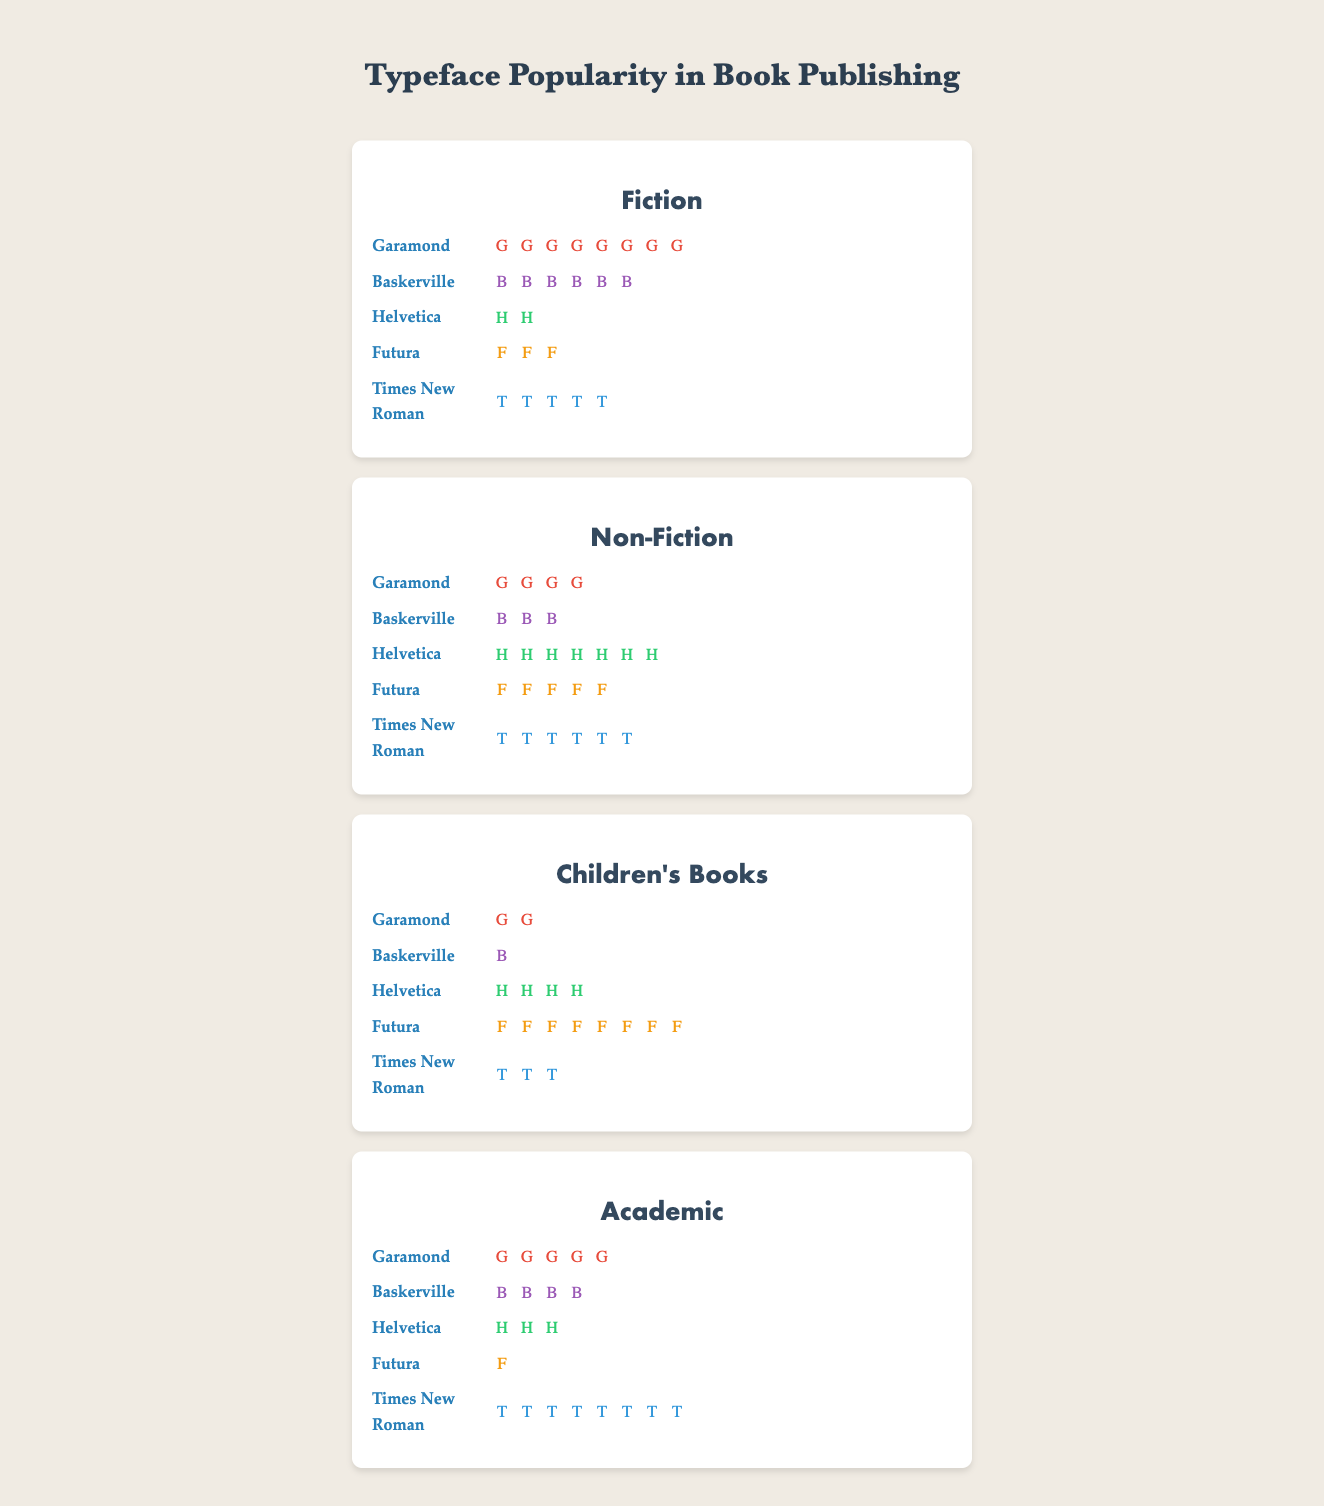What's the most popular typeface used in Fiction books? By looking at the figure, count the number of icons for each typeface in the Fiction section. Garamond has the most icons (8), making it the most popular.
Answer: Garamond Which genre uses Times New Roman the most? Compare the number of Times New Roman icons across all genres. The Academic genre has the most icons (8) for Times New Roman.
Answer: Academic How many total icons are used to represent Helvetica across all genres? Sum the number of Helvetica icons: Fiction (2) + Non-Fiction (7) + Children's Books (4) + Academic (3). The total is 2 + 7 + 4 + 3 = 16.
Answer: 16 Which typeface is used the least in Children's Books? In the Children's Books section, count the icons for each typeface. Baskerville has the least with only 1 icon.
Answer: Baskerville Between Garamond and Futura, which one is more popular in Non-Fiction? Count the number of icons for Garamond (4) and Futura (5) in the Non-Fiction section. Futura has more icons.
Answer: Futura What's the total number of icons used to represent all typefaces in the Academic genre? Sum the number of icons for all typefaces in the Academic genre: Garamond (5) + Baskerville (4) + Helvetica (3) + Futura (1) + Times New Roman (8). The total is 5 + 4 + 3 + 1 + 8 = 21.
Answer: 21 In which genre does Baskerville have the second highest number of icons? Look at the number of Baskerville icons in each genre: Fiction (6), Non-Fiction (3), Children's Books (1), Academic (4). The second highest number is in the Academic genre with 4 icons.
Answer: Academic How many more icons does Futura have in Children's Books compared to Fiction? In the Fiction section, Futura has 3 icons. In Children's Books, Futura has 8 icons. The difference is 8 - 3 = 5.
Answer: 5 Which typeface has the same number of icons in both Fiction and Non-Fiction genres? Compare the number of icons for each typeface between the Fiction and Non-Fiction sections: Garamond (8, 4), Baskerville (6, 3), Helvetica (2, 7), Futura (3, 5), Times New Roman (5, 6). None have the same number of icons.
Answer: None 